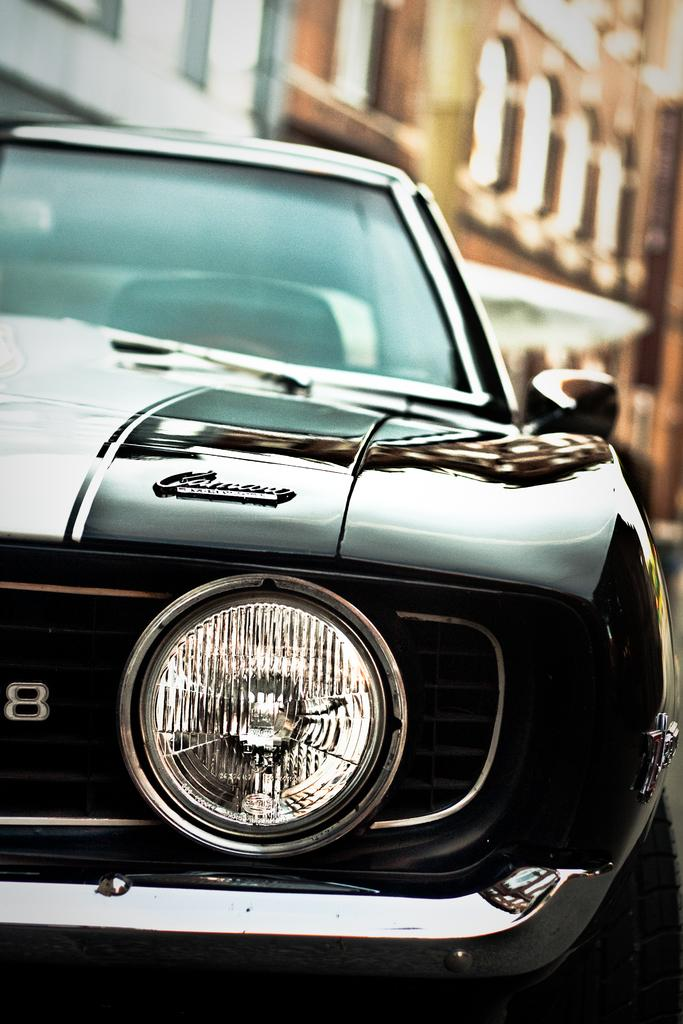What is the main subject in the front of the image? There is a car in the front of the image. What can be seen in the background of the image? There are buildings in the background of the image. What type of boundary is visible in the image? There is no boundary visible in the image; it only features a car and buildings in the background. 